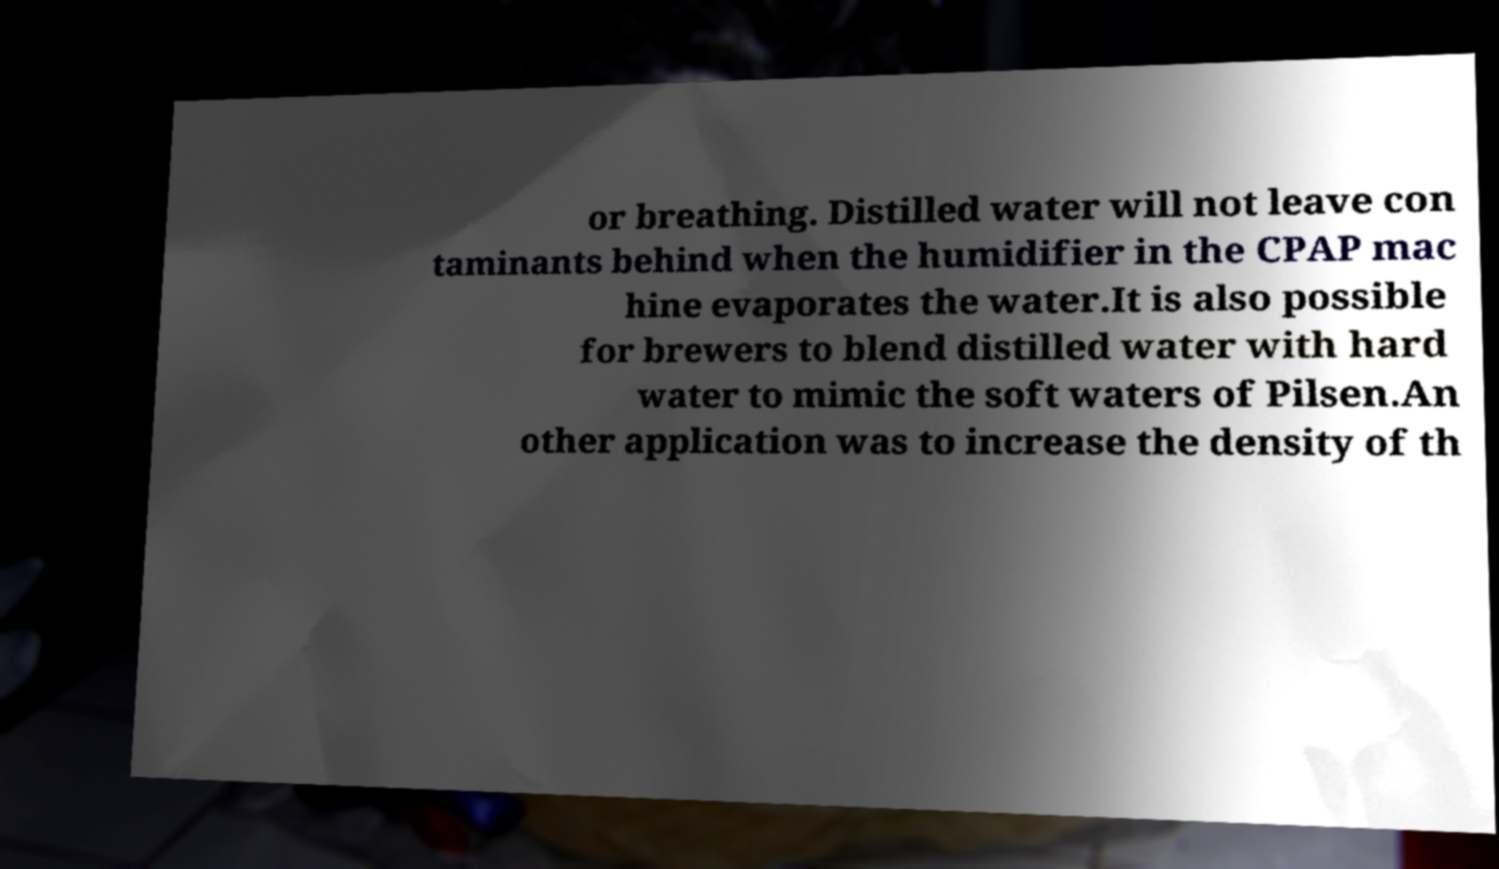Can you accurately transcribe the text from the provided image for me? or breathing. Distilled water will not leave con taminants behind when the humidifier in the CPAP mac hine evaporates the water.It is also possible for brewers to blend distilled water with hard water to mimic the soft waters of Pilsen.An other application was to increase the density of th 